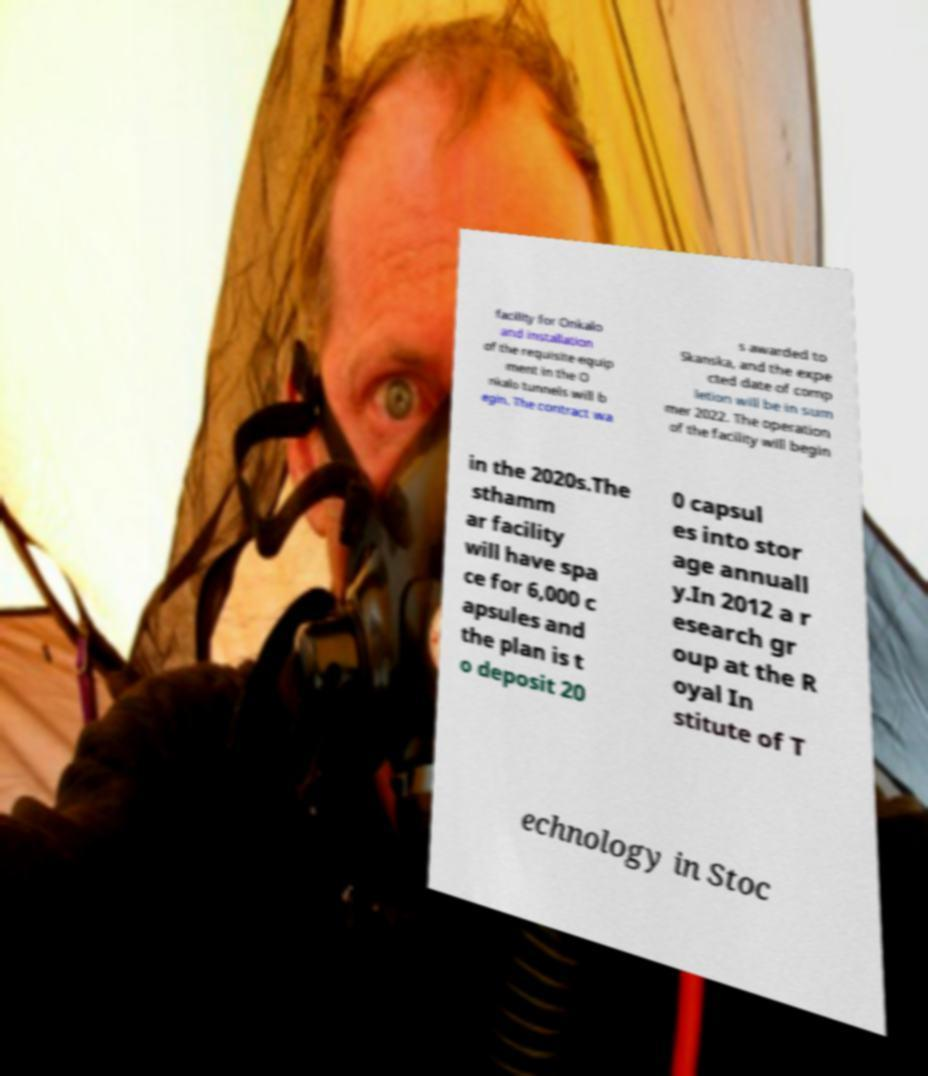Could you assist in decoding the text presented in this image and type it out clearly? facility for Onkalo and installation of the requisite equip ment in the O nkalo tunnels will b egin. The contract wa s awarded to Skanska, and the expe cted date of comp letion will be in sum mer 2022. The operation of the facility will begin in the 2020s.The sthamm ar facility will have spa ce for 6,000 c apsules and the plan is t o deposit 20 0 capsul es into stor age annuall y.In 2012 a r esearch gr oup at the R oyal In stitute of T echnology in Stoc 